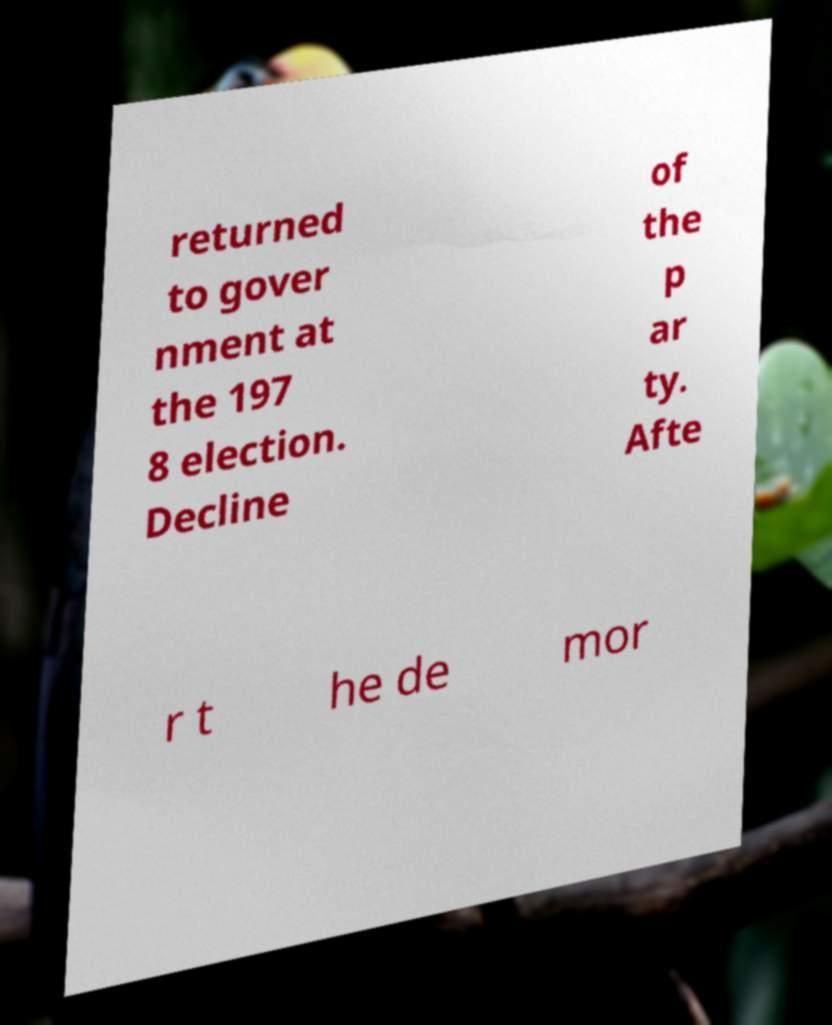There's text embedded in this image that I need extracted. Can you transcribe it verbatim? returned to gover nment at the 197 8 election. Decline of the p ar ty. Afte r t he de mor 